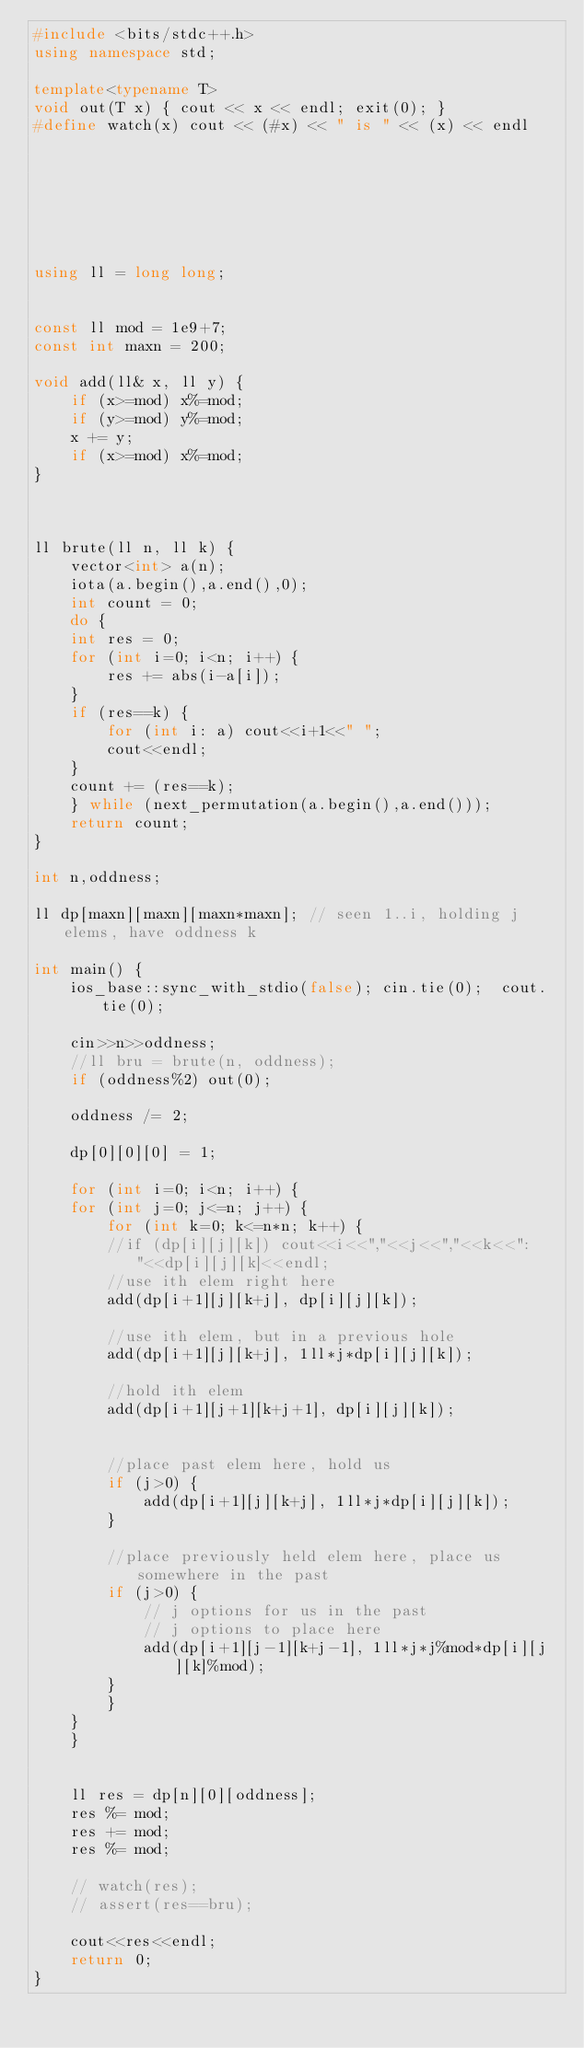Convert code to text. <code><loc_0><loc_0><loc_500><loc_500><_C++_>#include <bits/stdc++.h>
using namespace std;

template<typename T>
void out(T x) { cout << x << endl; exit(0); }
#define watch(x) cout << (#x) << " is " << (x) << endl







using ll = long long;


const ll mod = 1e9+7;
const int maxn = 200;

void add(ll& x, ll y) {
    if (x>=mod) x%=mod;
    if (y>=mod) y%=mod;
    x += y;
    if (x>=mod) x%=mod;
}



ll brute(ll n, ll k) {
    vector<int> a(n);
    iota(a.begin(),a.end(),0);
    int count = 0;
    do {
	int res = 0;
	for (int i=0; i<n; i++) {
	    res += abs(i-a[i]);
	}
	if (res==k) {
	    for (int i: a) cout<<i+1<<" ";
	    cout<<endl;
	}
	count += (res==k);
    } while (next_permutation(a.begin(),a.end()));
    return count;
}

int n,oddness;

ll dp[maxn][maxn][maxn*maxn]; // seen 1..i, holding j elems, have oddness k

int main() {
    ios_base::sync_with_stdio(false); cin.tie(0);  cout.tie(0);

    cin>>n>>oddness;
    //ll bru = brute(n, oddness);
    if (oddness%2) out(0);

    oddness /= 2;

    dp[0][0][0] = 1;

    for (int i=0; i<n; i++) {
	for (int j=0; j<=n; j++) {
	    for (int k=0; k<=n*n; k++) {
		//if (dp[i][j][k]) cout<<i<<","<<j<<","<<k<<": "<<dp[i][j][k]<<endl;
		//use ith elem right here
		add(dp[i+1][j][k+j], dp[i][j][k]);

		//use ith elem, but in a previous hole
		add(dp[i+1][j][k+j], 1ll*j*dp[i][j][k]);

		//hold ith elem
		add(dp[i+1][j+1][k+j+1], dp[i][j][k]);


		//place past elem here, hold us
		if (j>0) {
		    add(dp[i+1][j][k+j], 1ll*j*dp[i][j][k]);
		}

		//place previously held elem here, place us somewhere in the past
		if (j>0) {
		    // j options for us in the past
		    // j options to place here
		    add(dp[i+1][j-1][k+j-1], 1ll*j*j%mod*dp[i][j][k]%mod);
		}
	    }
	}
    }


    ll res = dp[n][0][oddness];
    res %= mod;
    res += mod;
    res %= mod;

    // watch(res);
    // assert(res==bru);

    cout<<res<<endl;    
    return 0;
}
</code> 